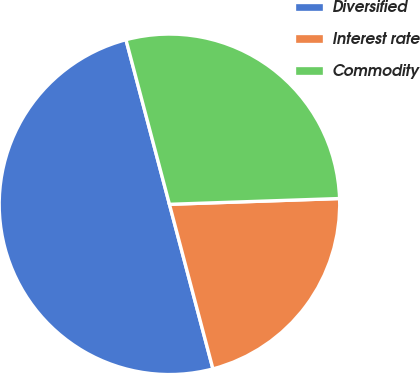Convert chart to OTSL. <chart><loc_0><loc_0><loc_500><loc_500><pie_chart><fcel>Diversified<fcel>Interest rate<fcel>Commodity<nl><fcel>50.0%<fcel>21.43%<fcel>28.57%<nl></chart> 